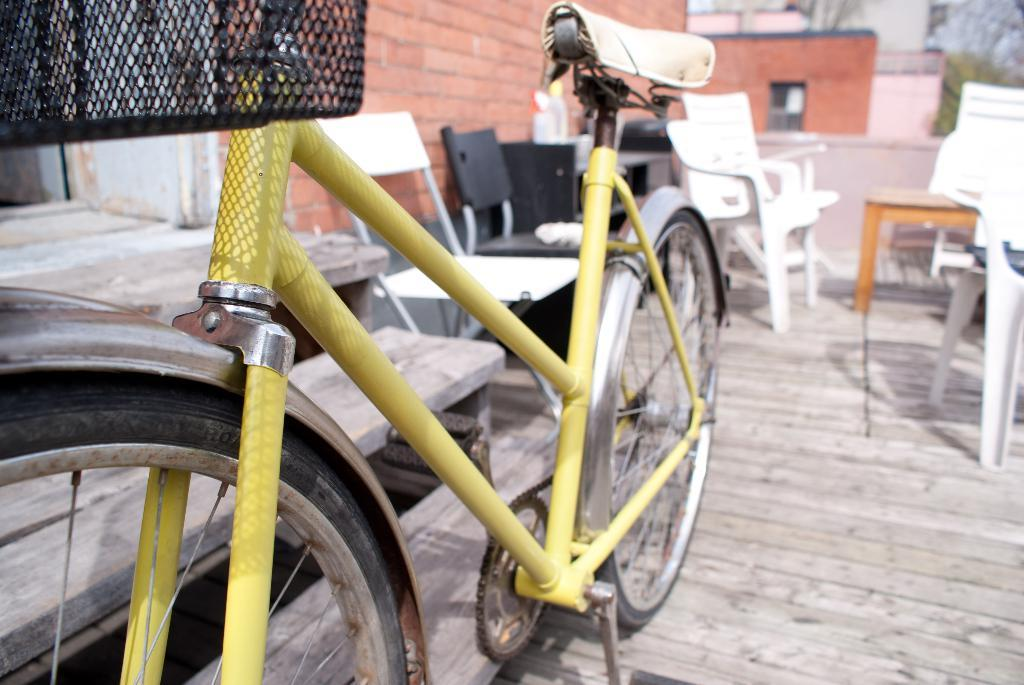What is the main object in the image? There is a bicycle in the image. What architectural feature is present in the image? There is a staircase in the image. What type of furniture is visible in the image? There are chairs in the image. What material is the wall made of in the image? The wall is made of bricks in the image. What type of apparel is the bicycle wearing in the image? The bicycle is not wearing any apparel in the image, as it is an inanimate object. 